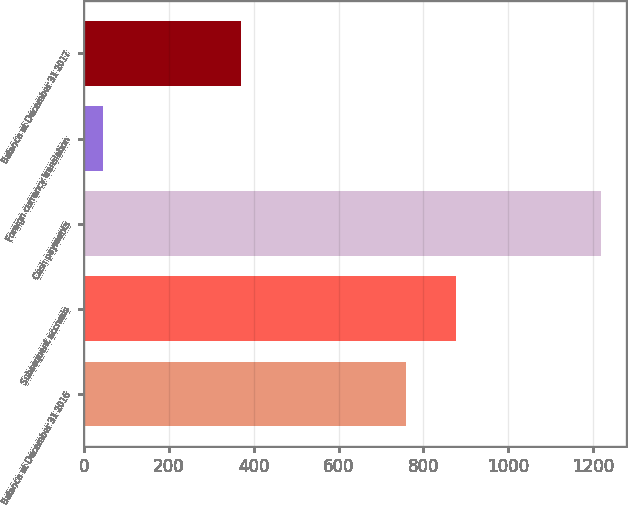<chart> <loc_0><loc_0><loc_500><loc_500><bar_chart><fcel>Balance at December 31 2016<fcel>Subsequent accruals<fcel>Cash payments<fcel>Foreign currency translation<fcel>Balance at December 31 2017<nl><fcel>760<fcel>877.4<fcel>1218<fcel>44<fcel>369<nl></chart> 